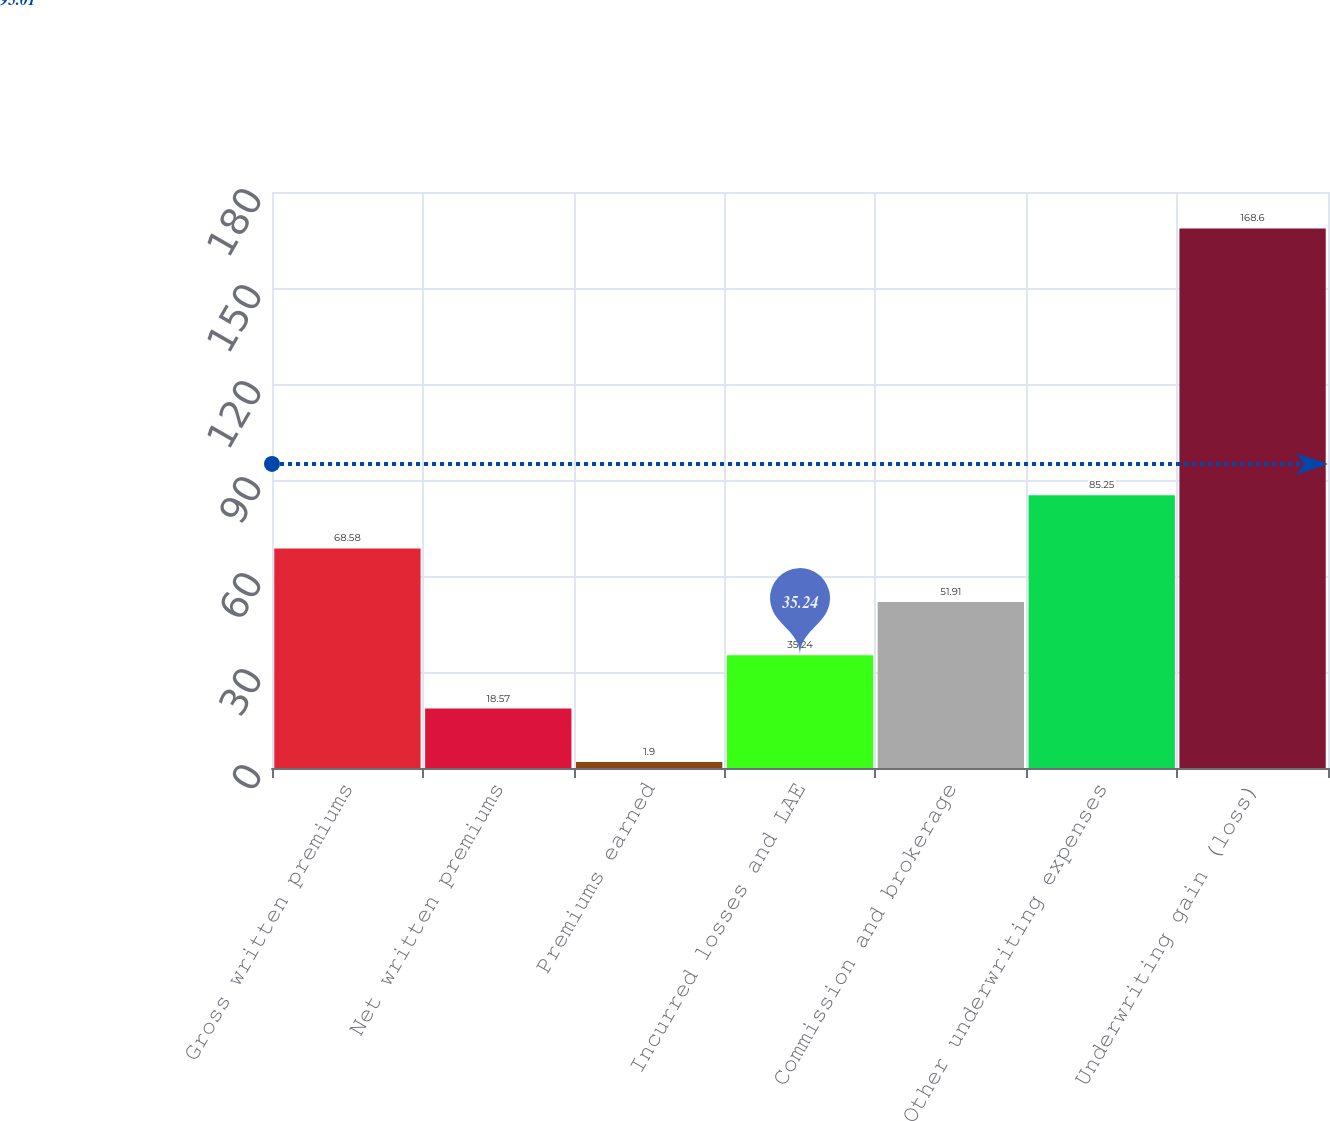Convert chart to OTSL. <chart><loc_0><loc_0><loc_500><loc_500><bar_chart><fcel>Gross written premiums<fcel>Net written premiums<fcel>Premiums earned<fcel>Incurred losses and LAE<fcel>Commission and brokerage<fcel>Other underwriting expenses<fcel>Underwriting gain (loss)<nl><fcel>68.58<fcel>18.57<fcel>1.9<fcel>35.24<fcel>51.91<fcel>85.25<fcel>168.6<nl></chart> 